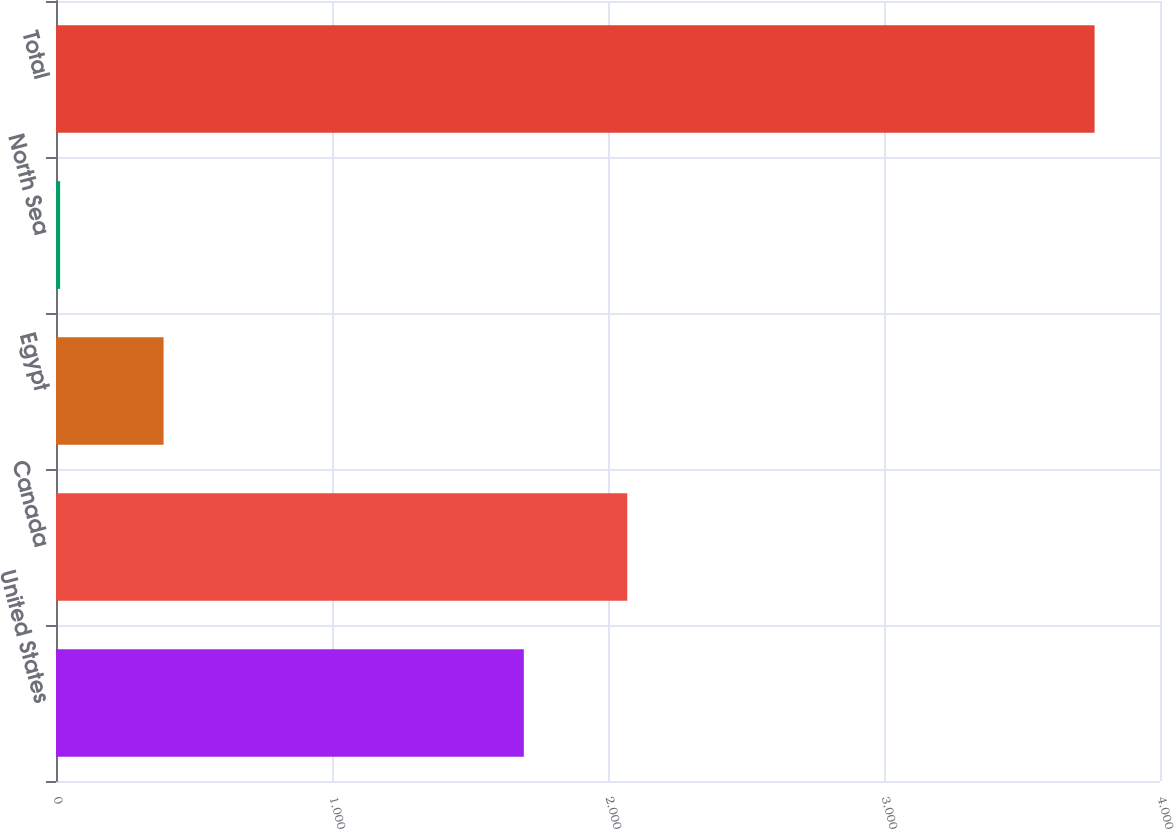Convert chart. <chart><loc_0><loc_0><loc_500><loc_500><bar_chart><fcel>United States<fcel>Canada<fcel>Egypt<fcel>North Sea<fcel>Total<nl><fcel>1695<fcel>2069.8<fcel>389.8<fcel>15<fcel>3763<nl></chart> 